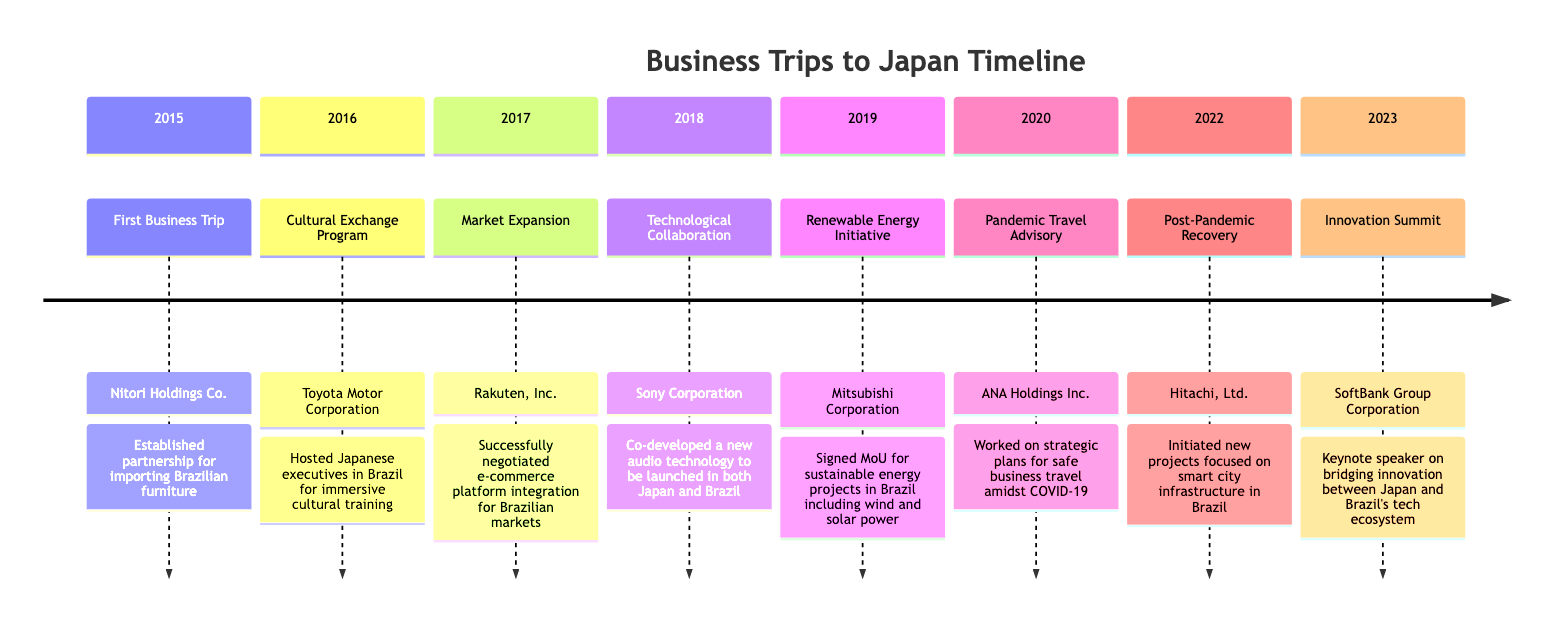What was the first business trip year? The data mentions that the first business trip occurred in the year 2015, as highlighted in the first section of the timeline.
Answer: 2015 Who was the company involved in the 2019 trip? Referring to the 2019 section of the diagram, it states that Mitsubishi Corporation was the company involved during that trip.
Answer: Mitsubishi Corporation How many trips are recorded in the timeline? By counting the sections of the timeline from 2015 to 2023, there are a total of eight recorded trips.
Answer: 8 What was the highlight of the 2022 trip? The highlight for the trip in 2022 is identified as "Post-Pandemic Recovery," which is explicitly noted in that section.
Answer: Post-Pandemic Recovery What accomplishment was achieved in 2018? The accomplishment mentioned for the 2018 trip indicates that new audio technology was co-developed to be launched in both Japan and Brazil, as written in the respective section.
Answer: Co-developed a new audio technology For which company was the cultural exchange initiated in 2016? The timeline for 2016 specifies that Toyota Motor Corporation was the company involved in the cultural exchange program during that trip.
Answer: Toyota Motor Corporation What accomplishment is associated with the 2023 trip? Looking at the 2023 section, it states that the accomplishment was being a keynote speaker on innovation between Japan and Brazil's tech ecosystem.
Answer: Keynote speaker on bridging innovation Which trip focused on renewable energy? The timeline for 2019 shows that the trip's focus was on renewable energy initiatives and involved Mitsubishi Corporation, making it clear that this was the relevant trip for that topic.
Answer: Renewable Energy Initiative 